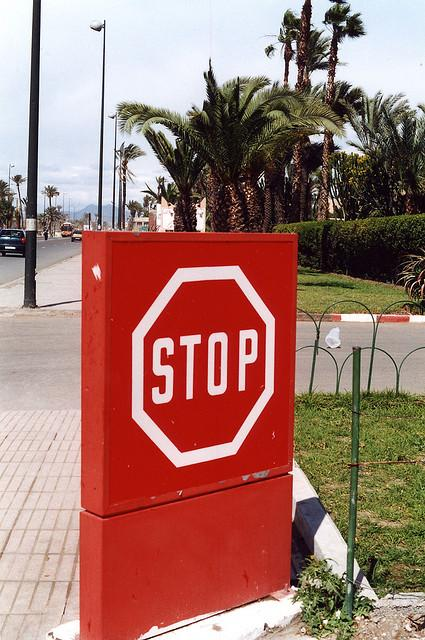Where can we find the sign above?

Choices:
A) kitchen
B) ocean
C) road
D) home road 